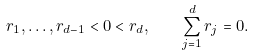Convert formula to latex. <formula><loc_0><loc_0><loc_500><loc_500>r _ { 1 } , \dots , r _ { d - 1 } < 0 < r _ { d } , \quad \sum _ { j = 1 } ^ { d } r _ { j } = 0 .</formula> 